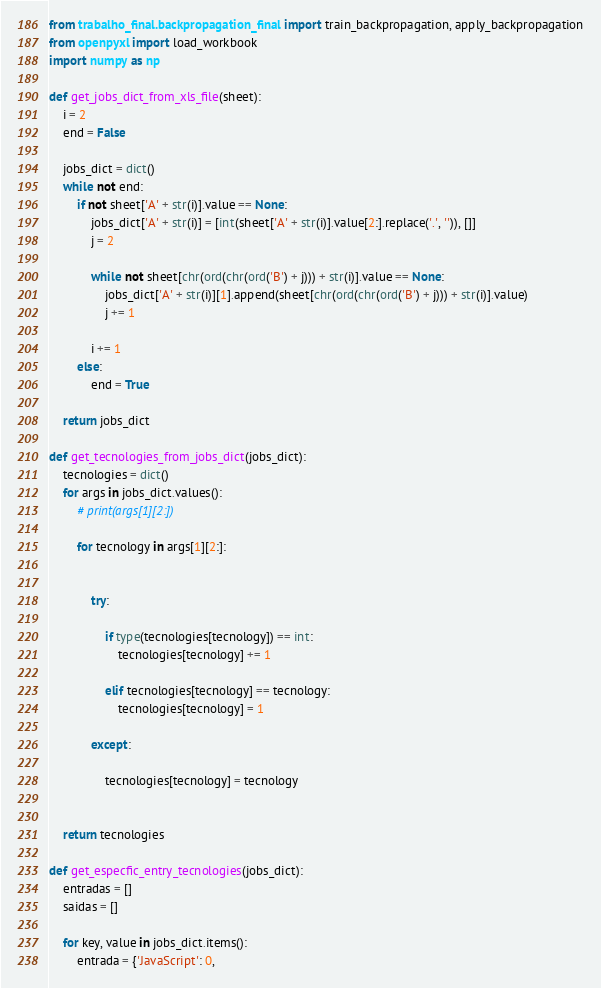Convert code to text. <code><loc_0><loc_0><loc_500><loc_500><_Python_>from trabalho_final.backpropagation_final import train_backpropagation, apply_backpropagation
from openpyxl import load_workbook
import numpy as np

def get_jobs_dict_from_xls_file(sheet):
    i = 2
    end = False

    jobs_dict = dict()
    while not end:
        if not sheet['A' + str(i)].value == None:
            jobs_dict['A' + str(i)] = [int(sheet['A' + str(i)].value[2:].replace('.', '')), []]
            j = 2

            while not sheet[chr(ord(chr(ord('B') + j))) + str(i)].value == None:
                jobs_dict['A' + str(i)][1].append(sheet[chr(ord(chr(ord('B') + j))) + str(i)].value)
                j += 1

            i += 1
        else:
            end = True

    return jobs_dict

def get_tecnologies_from_jobs_dict(jobs_dict):
    tecnologies = dict()
    for args in jobs_dict.values():
        # print(args[1][2:])

        for tecnology in args[1][2:]:


            try:

                if type(tecnologies[tecnology]) == int:
                    tecnologies[tecnology] += 1

                elif tecnologies[tecnology] == tecnology:
                    tecnologies[tecnology] = 1

            except:

                tecnologies[tecnology] = tecnology


    return tecnologies

def get_especfic_entry_tecnologies(jobs_dict):
    entradas = []
    saidas = []

    for key, value in jobs_dict.items():
        entrada = {'JavaScript': 0,</code> 